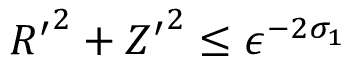<formula> <loc_0><loc_0><loc_500><loc_500>{ R ^ { \prime } } ^ { 2 } + { Z ^ { \prime } } ^ { 2 } \leq \epsilon ^ { - 2 \sigma _ { 1 } }</formula> 